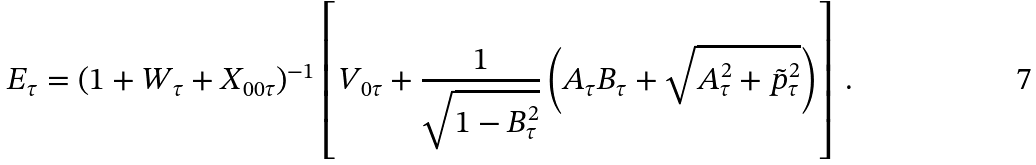Convert formula to latex. <formula><loc_0><loc_0><loc_500><loc_500>E _ { \tau } = ( 1 + W _ { \tau } + X _ { 0 0 \tau } ) ^ { - 1 } \left [ V _ { 0 \tau } + \frac { 1 } { \sqrt { 1 - B _ { \tau } ^ { 2 } } } \left ( A _ { \tau } B _ { \tau } + \sqrt { A _ { \tau } ^ { 2 } + \tilde { p } _ { \tau } ^ { 2 } } \right ) \right ] \, .</formula> 